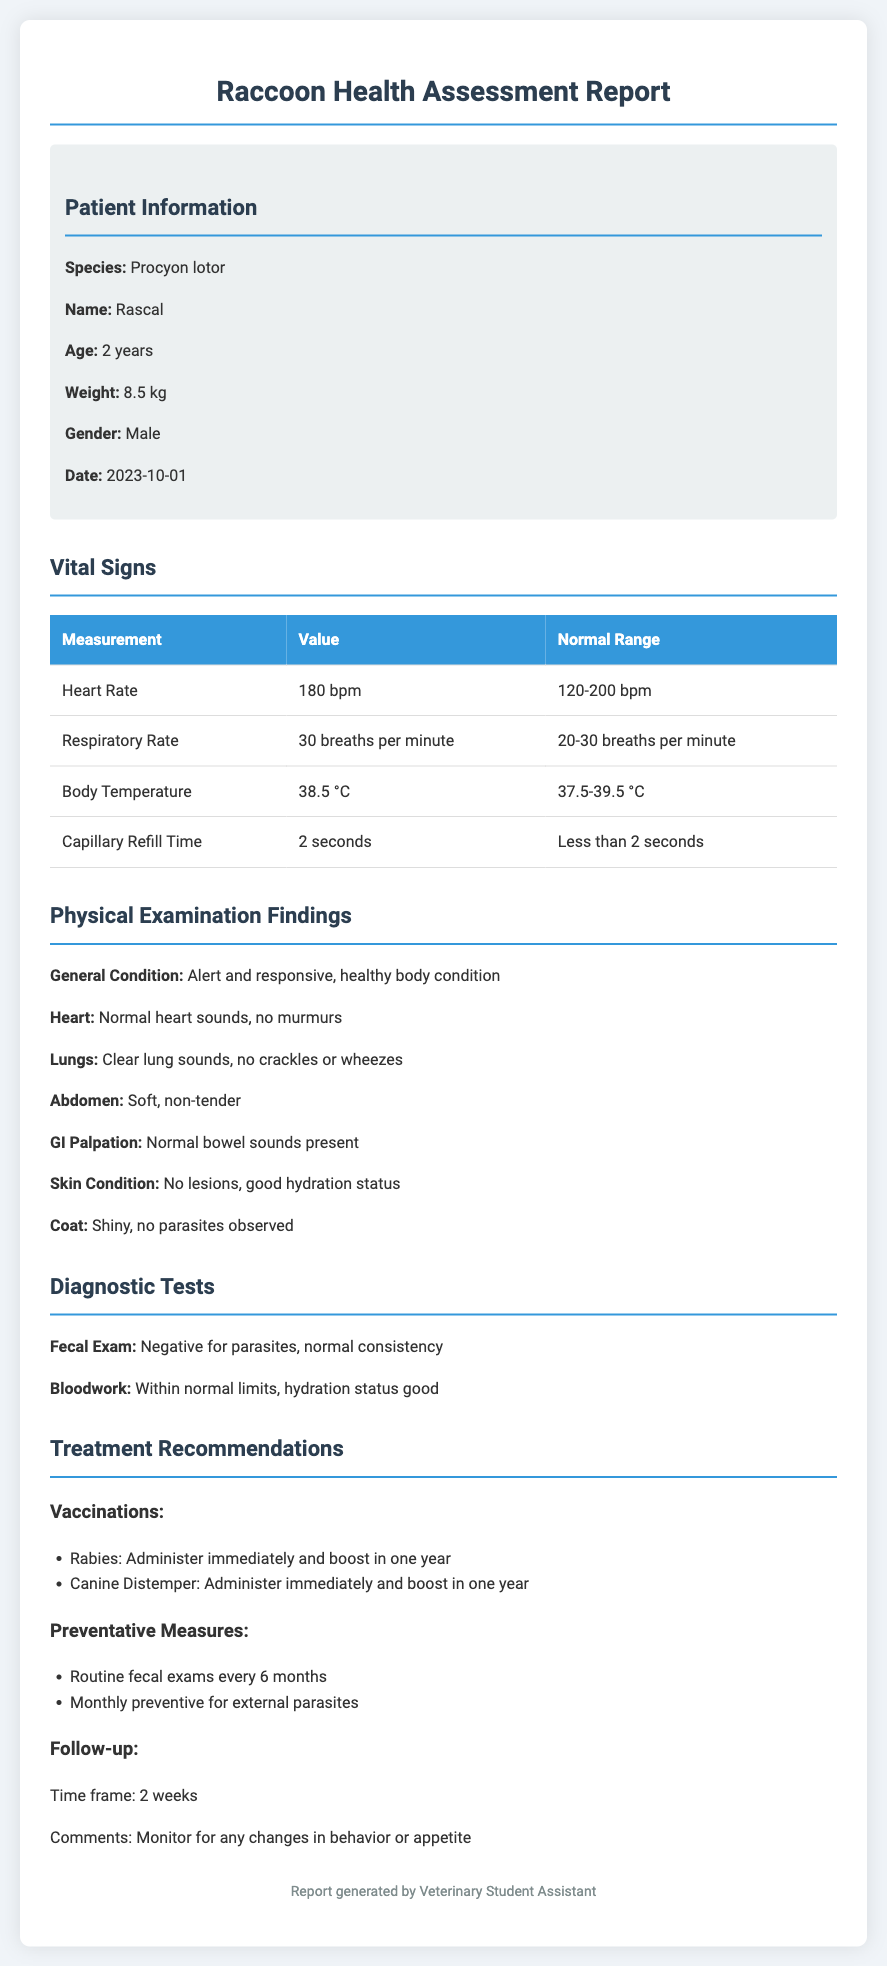What is the name of the raccoon? The patient's name is mentioned in the patient information section of the document.
Answer: Rascal What is the age of the raccoon? The age of the raccoon is specified in the patient information section.
Answer: 2 years What is the body temperature recorded? The body temperature is listed under the vital signs section.
Answer: 38.5 °C What is the heart rate range for a healthy raccoon? The normal heart rate range is provided alongside the recorded heart rate.
Answer: 120-200 bpm How long should the follow-up be scheduled for? The time frame for the follow-up is mentioned in the treatment recommendations section.
Answer: 2 weeks What does the fecal exam result indicate? The result of the fecal exam is highlighted in the diagnostic tests section.
Answer: Negative for parasites What is recommended for rabies vaccination? The recommendations for rabies vaccination are noted in the treatment recommendations section.
Answer: Administer immediately and boost in one year How many breaths per minute is the respiratory rate? The respiratory rate is given in the vital signs table in the document.
Answer: 30 breaths per minute What is the general condition of Rascal according to the physical examination? The general condition is described in the physical examination findings.
Answer: Alert and responsive, healthy body condition 